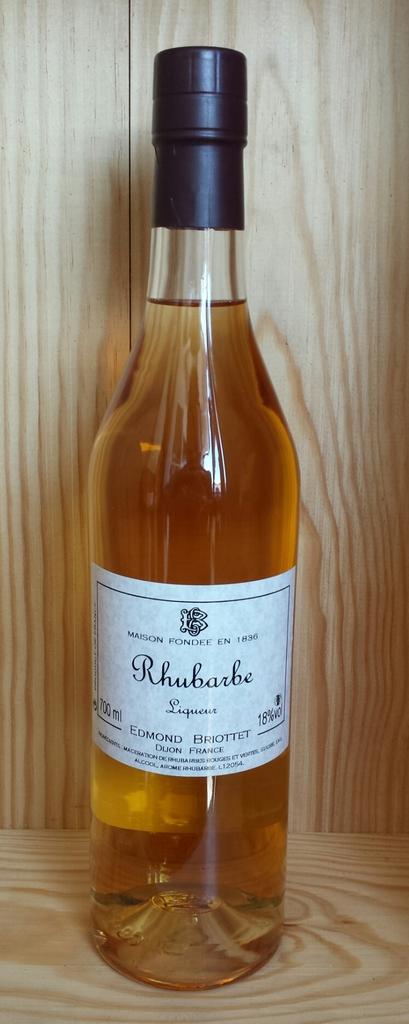What kind of wine is this?
Keep it short and to the point. Rhubarbe. What is the alcohol content of this wine?
Make the answer very short. 18%. 